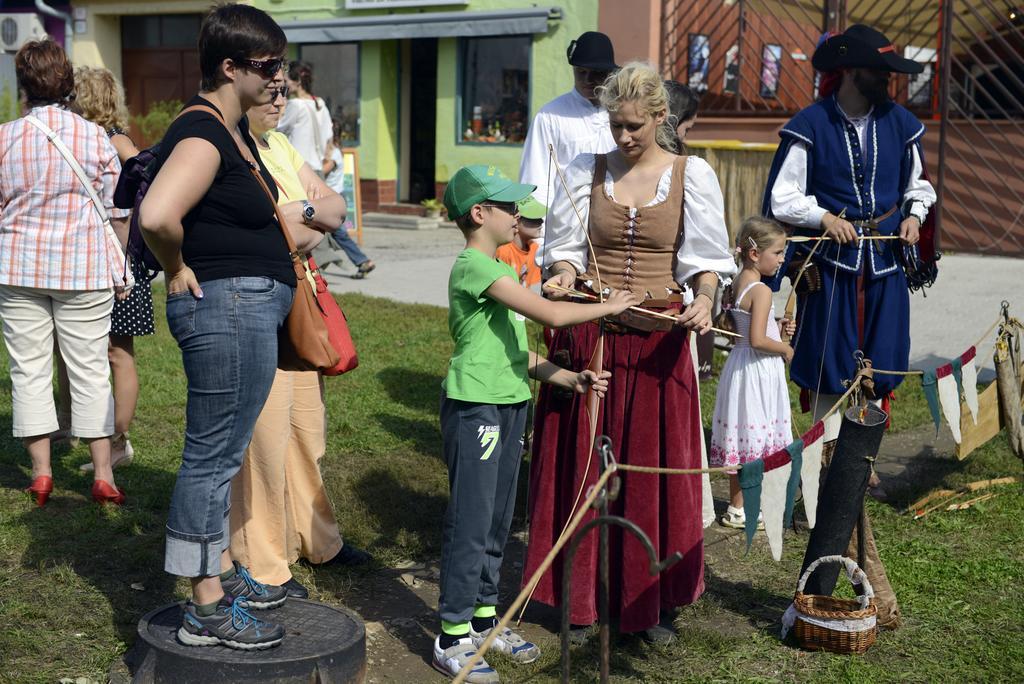Describe this image in one or two sentences. In this image we can see people standing. At the bottom there is a fence and we can see a basket placed on the grass. In the background there are buildings. 